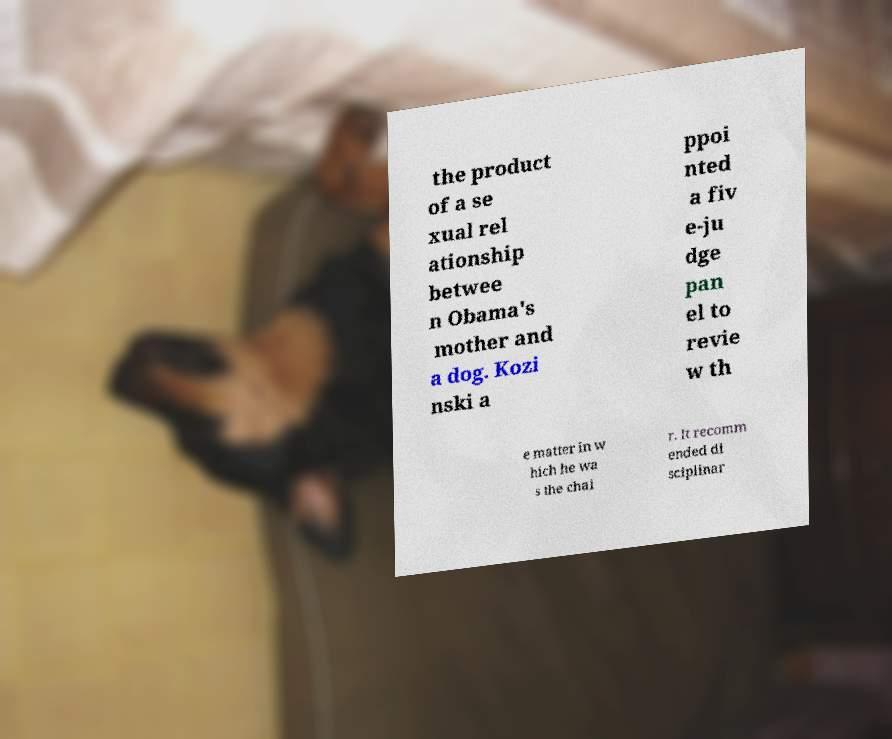Can you accurately transcribe the text from the provided image for me? the product of a se xual rel ationship betwee n Obama's mother and a dog. Kozi nski a ppoi nted a fiv e-ju dge pan el to revie w th e matter in w hich he wa s the chai r. It recomm ended di sciplinar 